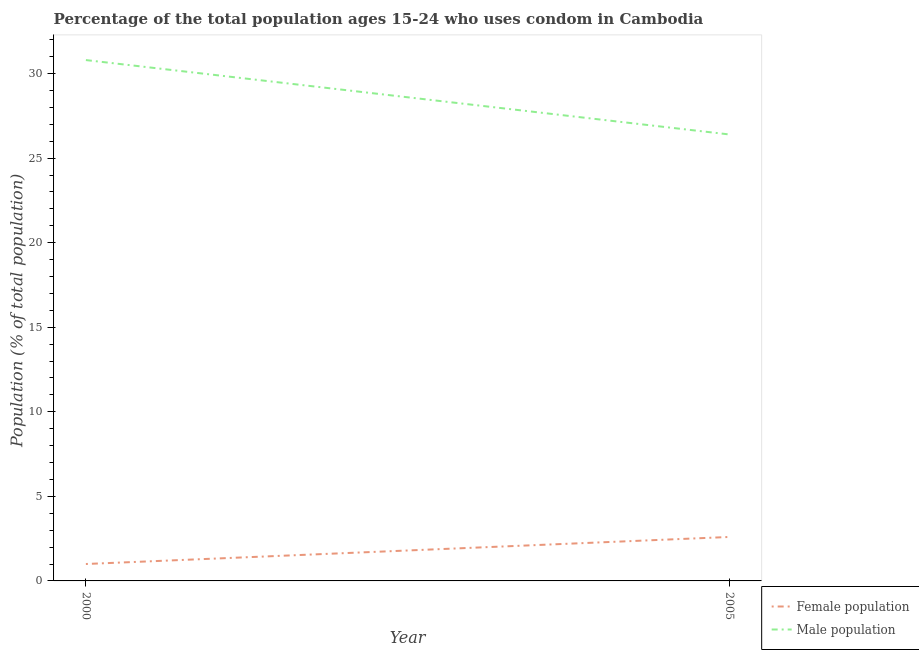Does the line corresponding to male population intersect with the line corresponding to female population?
Keep it short and to the point. No. Across all years, what is the maximum female population?
Provide a short and direct response. 2.6. In which year was the male population maximum?
Your response must be concise. 2000. What is the difference between the male population in 2000 and that in 2005?
Ensure brevity in your answer.  4.4. What is the difference between the male population in 2005 and the female population in 2000?
Offer a terse response. 25.4. In the year 2000, what is the difference between the male population and female population?
Your answer should be very brief. 29.8. What is the ratio of the female population in 2000 to that in 2005?
Your answer should be compact. 0.38. Is the female population in 2000 less than that in 2005?
Give a very brief answer. Yes. Does the female population monotonically increase over the years?
Offer a terse response. Yes. Is the female population strictly greater than the male population over the years?
Your answer should be very brief. No. Is the female population strictly less than the male population over the years?
Provide a succinct answer. Yes. How many years are there in the graph?
Your answer should be very brief. 2. Does the graph contain grids?
Provide a short and direct response. No. How many legend labels are there?
Your response must be concise. 2. How are the legend labels stacked?
Keep it short and to the point. Vertical. What is the title of the graph?
Your answer should be very brief. Percentage of the total population ages 15-24 who uses condom in Cambodia. What is the label or title of the Y-axis?
Offer a terse response. Population (% of total population) . What is the Population (% of total population)  of Male population in 2000?
Make the answer very short. 30.8. What is the Population (% of total population)  in Male population in 2005?
Make the answer very short. 26.4. Across all years, what is the maximum Population (% of total population)  in Female population?
Provide a succinct answer. 2.6. Across all years, what is the maximum Population (% of total population)  in Male population?
Your answer should be very brief. 30.8. Across all years, what is the minimum Population (% of total population)  of Male population?
Provide a succinct answer. 26.4. What is the total Population (% of total population)  of Female population in the graph?
Ensure brevity in your answer.  3.6. What is the total Population (% of total population)  in Male population in the graph?
Offer a very short reply. 57.2. What is the difference between the Population (% of total population)  in Female population in 2000 and that in 2005?
Ensure brevity in your answer.  -1.6. What is the difference between the Population (% of total population)  in Male population in 2000 and that in 2005?
Make the answer very short. 4.4. What is the difference between the Population (% of total population)  of Female population in 2000 and the Population (% of total population)  of Male population in 2005?
Provide a succinct answer. -25.4. What is the average Population (% of total population)  in Male population per year?
Give a very brief answer. 28.6. In the year 2000, what is the difference between the Population (% of total population)  of Female population and Population (% of total population)  of Male population?
Ensure brevity in your answer.  -29.8. In the year 2005, what is the difference between the Population (% of total population)  in Female population and Population (% of total population)  in Male population?
Offer a terse response. -23.8. What is the ratio of the Population (% of total population)  of Female population in 2000 to that in 2005?
Keep it short and to the point. 0.38. What is the difference between the highest and the second highest Population (% of total population)  in Female population?
Give a very brief answer. 1.6. 